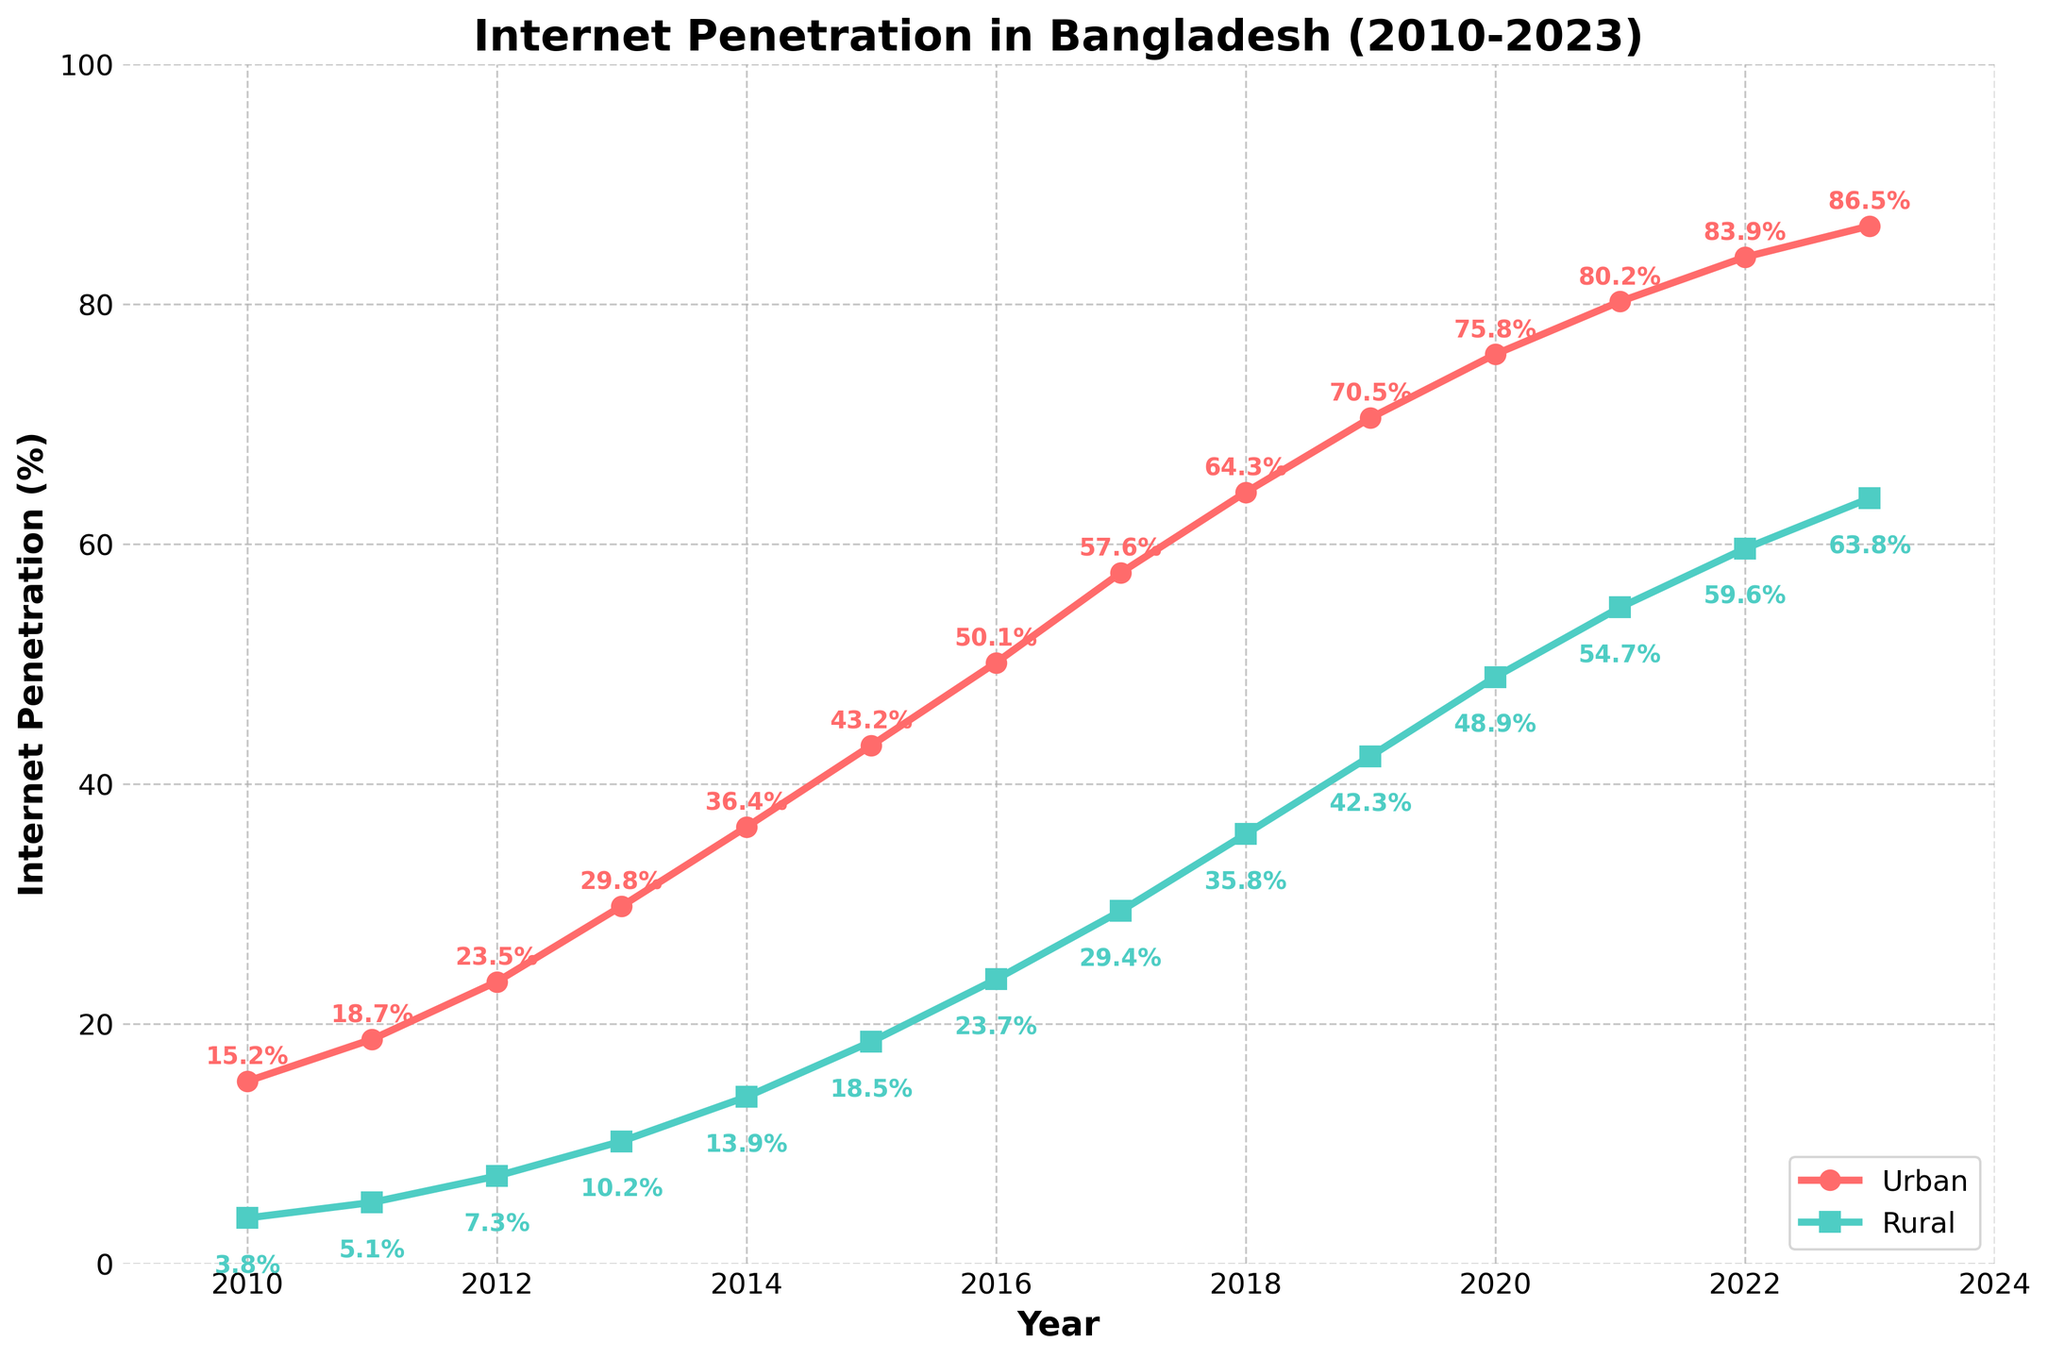What's the difference in internet penetration rates between urban and rural areas in 2023? The urban internet penetration rate in 2023 is 86.5%, and the rural rate is 63.8%. The difference is 86.5% - 63.8% = 22.7%.
Answer: 22.7% In which year did the urban internet penetration rate surpass 50%? Observing the urban internet penetration line, the rate surpassed 50% in 2016.
Answer: 2016 How many years did it take for the rural internet penetration to go from 10.2% to 48.9%? Rural penetration was 10.2% in 2013 and reached 48.9% in 2020. The difference in years is 2020 - 2013 = 7 years.
Answer: 7 years What is the average internet penetration rate for urban areas from 2010 to 2023? Sum the urban penetration rates from 2010 to 2023 and divide by the number of years: (15.2 + 18.7 + 23.5 + 29.8 + 36.4 + 43.2 + 50.1 + 57.6 + 64.3 + 70.5 + 75.8 + 80.2 + 83.9 + 86.5)/14 ≈ 49.4%
Answer: 49.4% Which year shows the highest growth in rural internet penetration rate compared to the previous year? Observing the slope of the rural line, the highest jump is from 2020 to 2021 (48.9% to 54.7%). The growth is 54.7% - 48.9% = 5.8%.
Answer: 2021 By how much did the urban internet penetration rate grow from 2010 to 2023? Urban penetration in 2010 was 15.2% and in 2023 is 86.5%. The growth is 86.5% - 15.2% = 71.3%.
Answer: 71.3% In what year did the rural internet penetration rate first exceed 40%? The rural internet penetration rate surpassed 40% in the year 2019 (42.3%).
Answer: 2019 If we average the penetration rates of urban and rural areas in 2015, what would be the result? Urban rate in 2015 is 43.2% and rural rate is 18.5%. Average = (43.2% + 18.5%)/2 = 30.85%.
Answer: 30.85% Describe the trend of internet penetration in urban vs. rural areas between 2010 and 2023. Both urban and rural areas show an increasing trend in internet penetration. Urban areas consistently have higher rates, but rural areas demonstrate substantial growth, particularly noticeable from 2013 onwards.
Answer: Increasing for both What is the percentage increase in rural internet penetration from 2016 to 2023? The rural penetration rate in 2016 was 23.7% and in 2023 is 63.8%. The percentage increase is ((63.8 - 23.7)/23.7) * 100 ≈ 169.6%.
Answer: 169.6% 